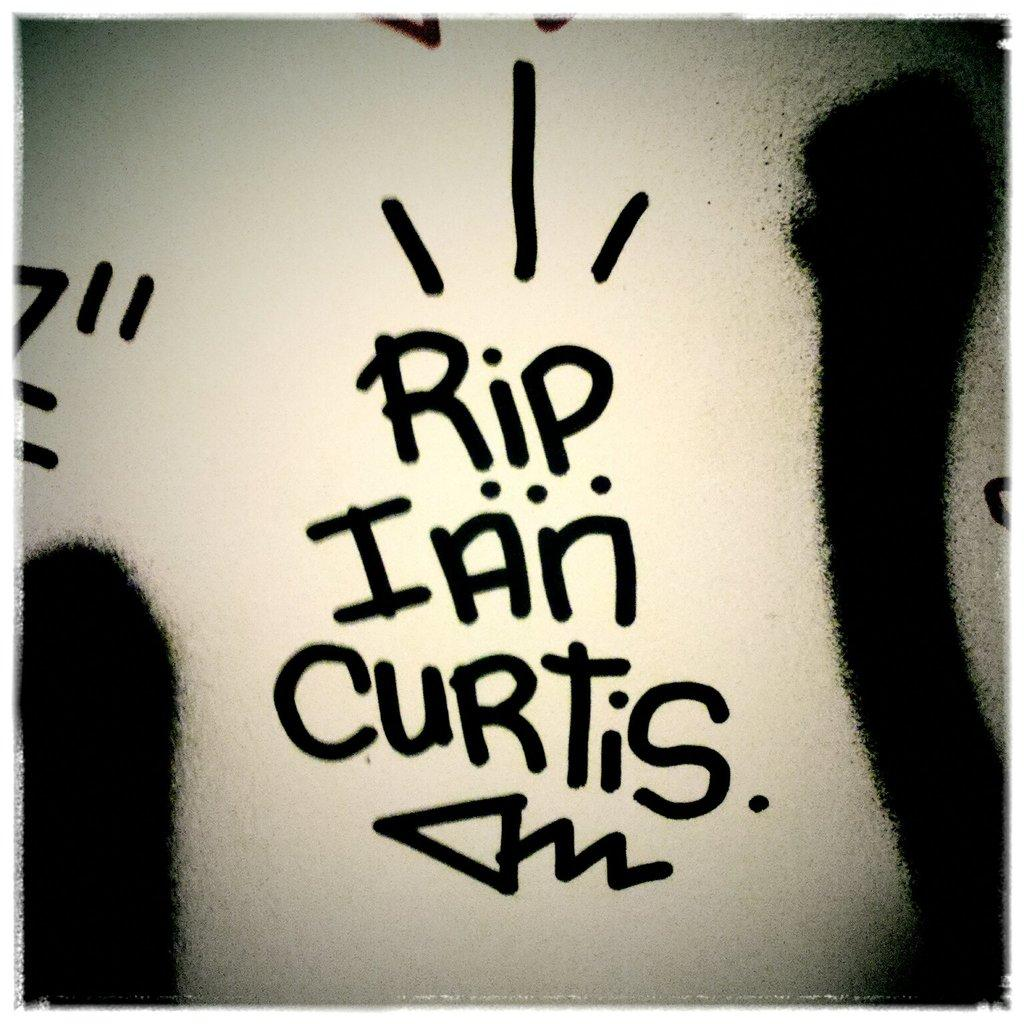<image>
Give a short and clear explanation of the subsequent image. A text written in marker on white that says "RIP Ian Curtis." 